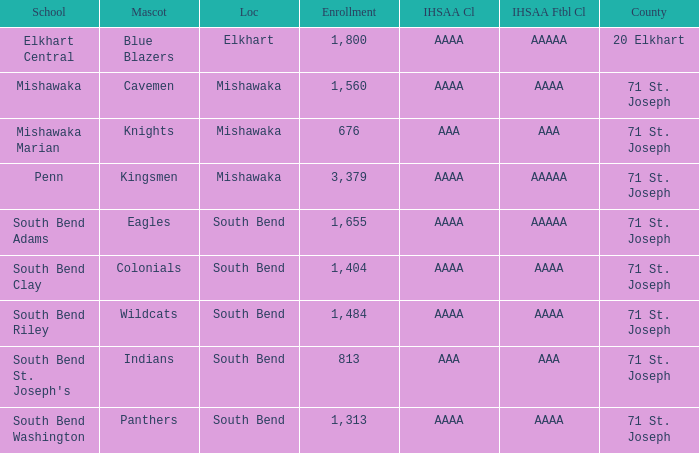What school has south bend as the location, with indians as the mascot? South Bend St. Joseph's. 